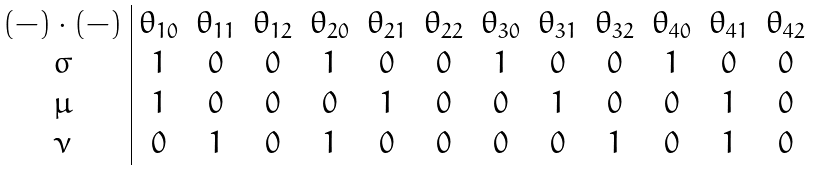<formula> <loc_0><loc_0><loc_500><loc_500>\begin{array} { c | c c c c c c c c c c c c } ( - ) \cdot ( - ) & \theta _ { 1 0 } & \theta _ { 1 1 } & \theta _ { 1 2 } & \theta _ { 2 0 } & \theta _ { 2 1 } & \theta _ { 2 2 } & \theta _ { 3 0 } & \theta _ { 3 1 } & \theta _ { 3 2 } & \theta _ { 4 0 } & \theta _ { 4 1 } & \theta _ { 4 2 } \\ \sigma & 1 & 0 & 0 & 1 & 0 & 0 & 1 & 0 & 0 & 1 & 0 & 0 \\ \mu & 1 & 0 & 0 & 0 & 1 & 0 & 0 & 1 & 0 & 0 & 1 & 0 \\ \nu & 0 & 1 & 0 & 1 & 0 & 0 & 0 & 0 & 1 & 0 & 1 & 0 \end{array}</formula> 